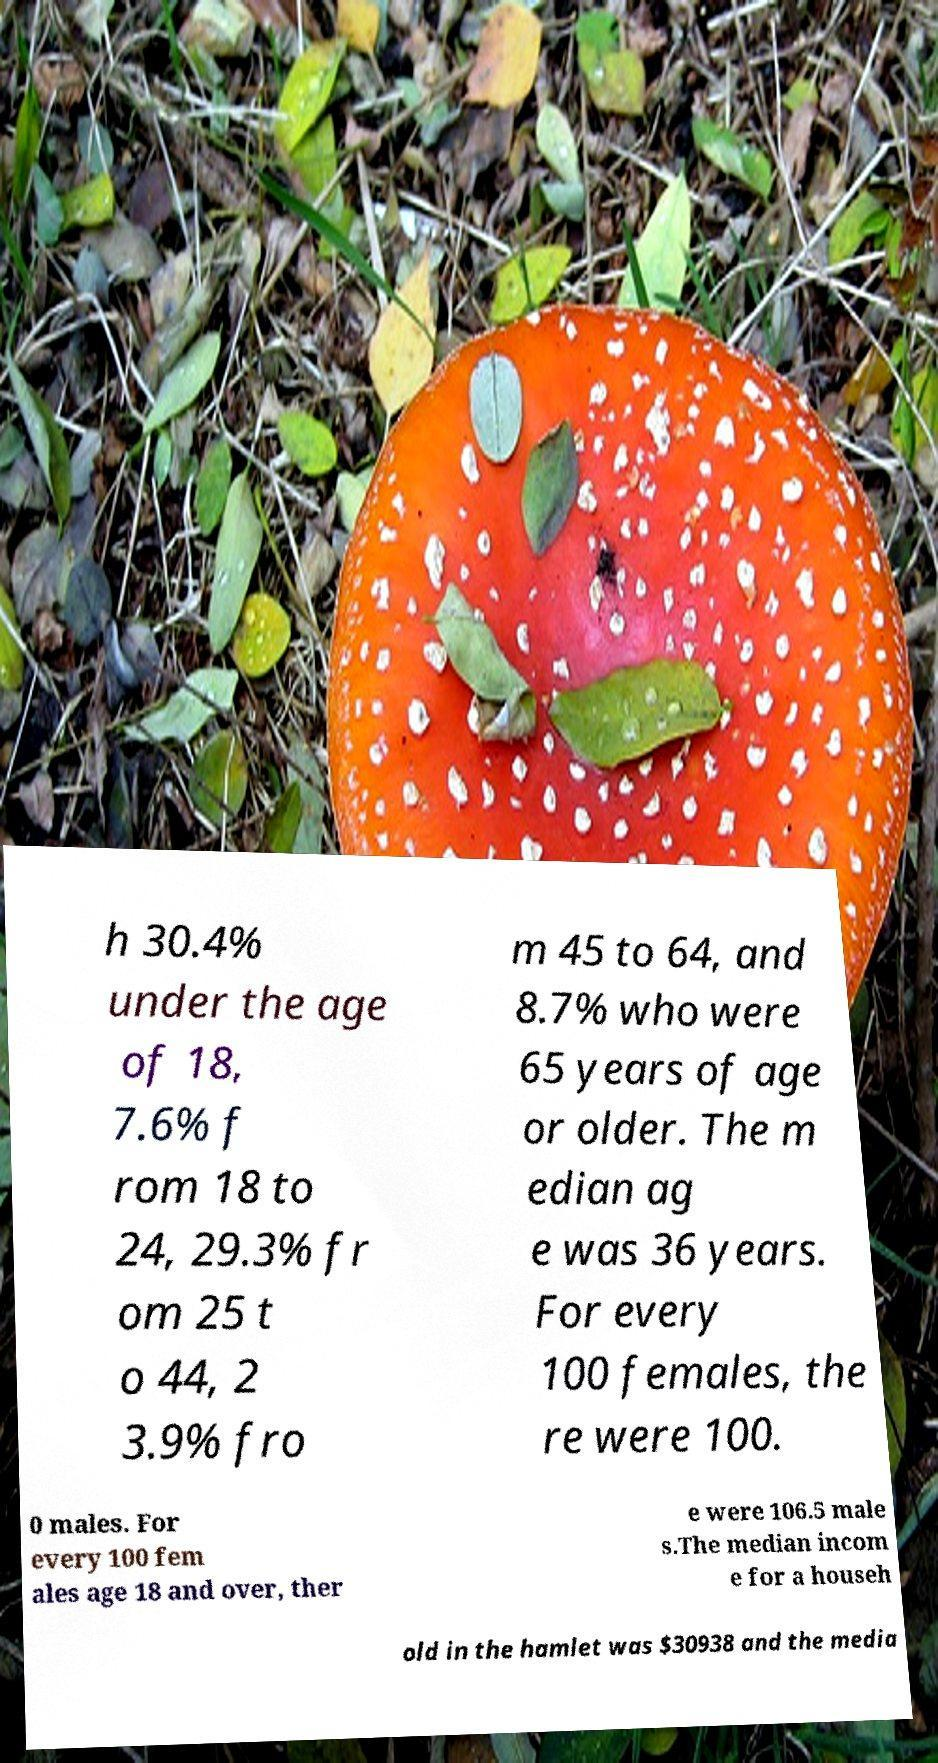Could you extract and type out the text from this image? h 30.4% under the age of 18, 7.6% f rom 18 to 24, 29.3% fr om 25 t o 44, 2 3.9% fro m 45 to 64, and 8.7% who were 65 years of age or older. The m edian ag e was 36 years. For every 100 females, the re were 100. 0 males. For every 100 fem ales age 18 and over, ther e were 106.5 male s.The median incom e for a househ old in the hamlet was $30938 and the media 